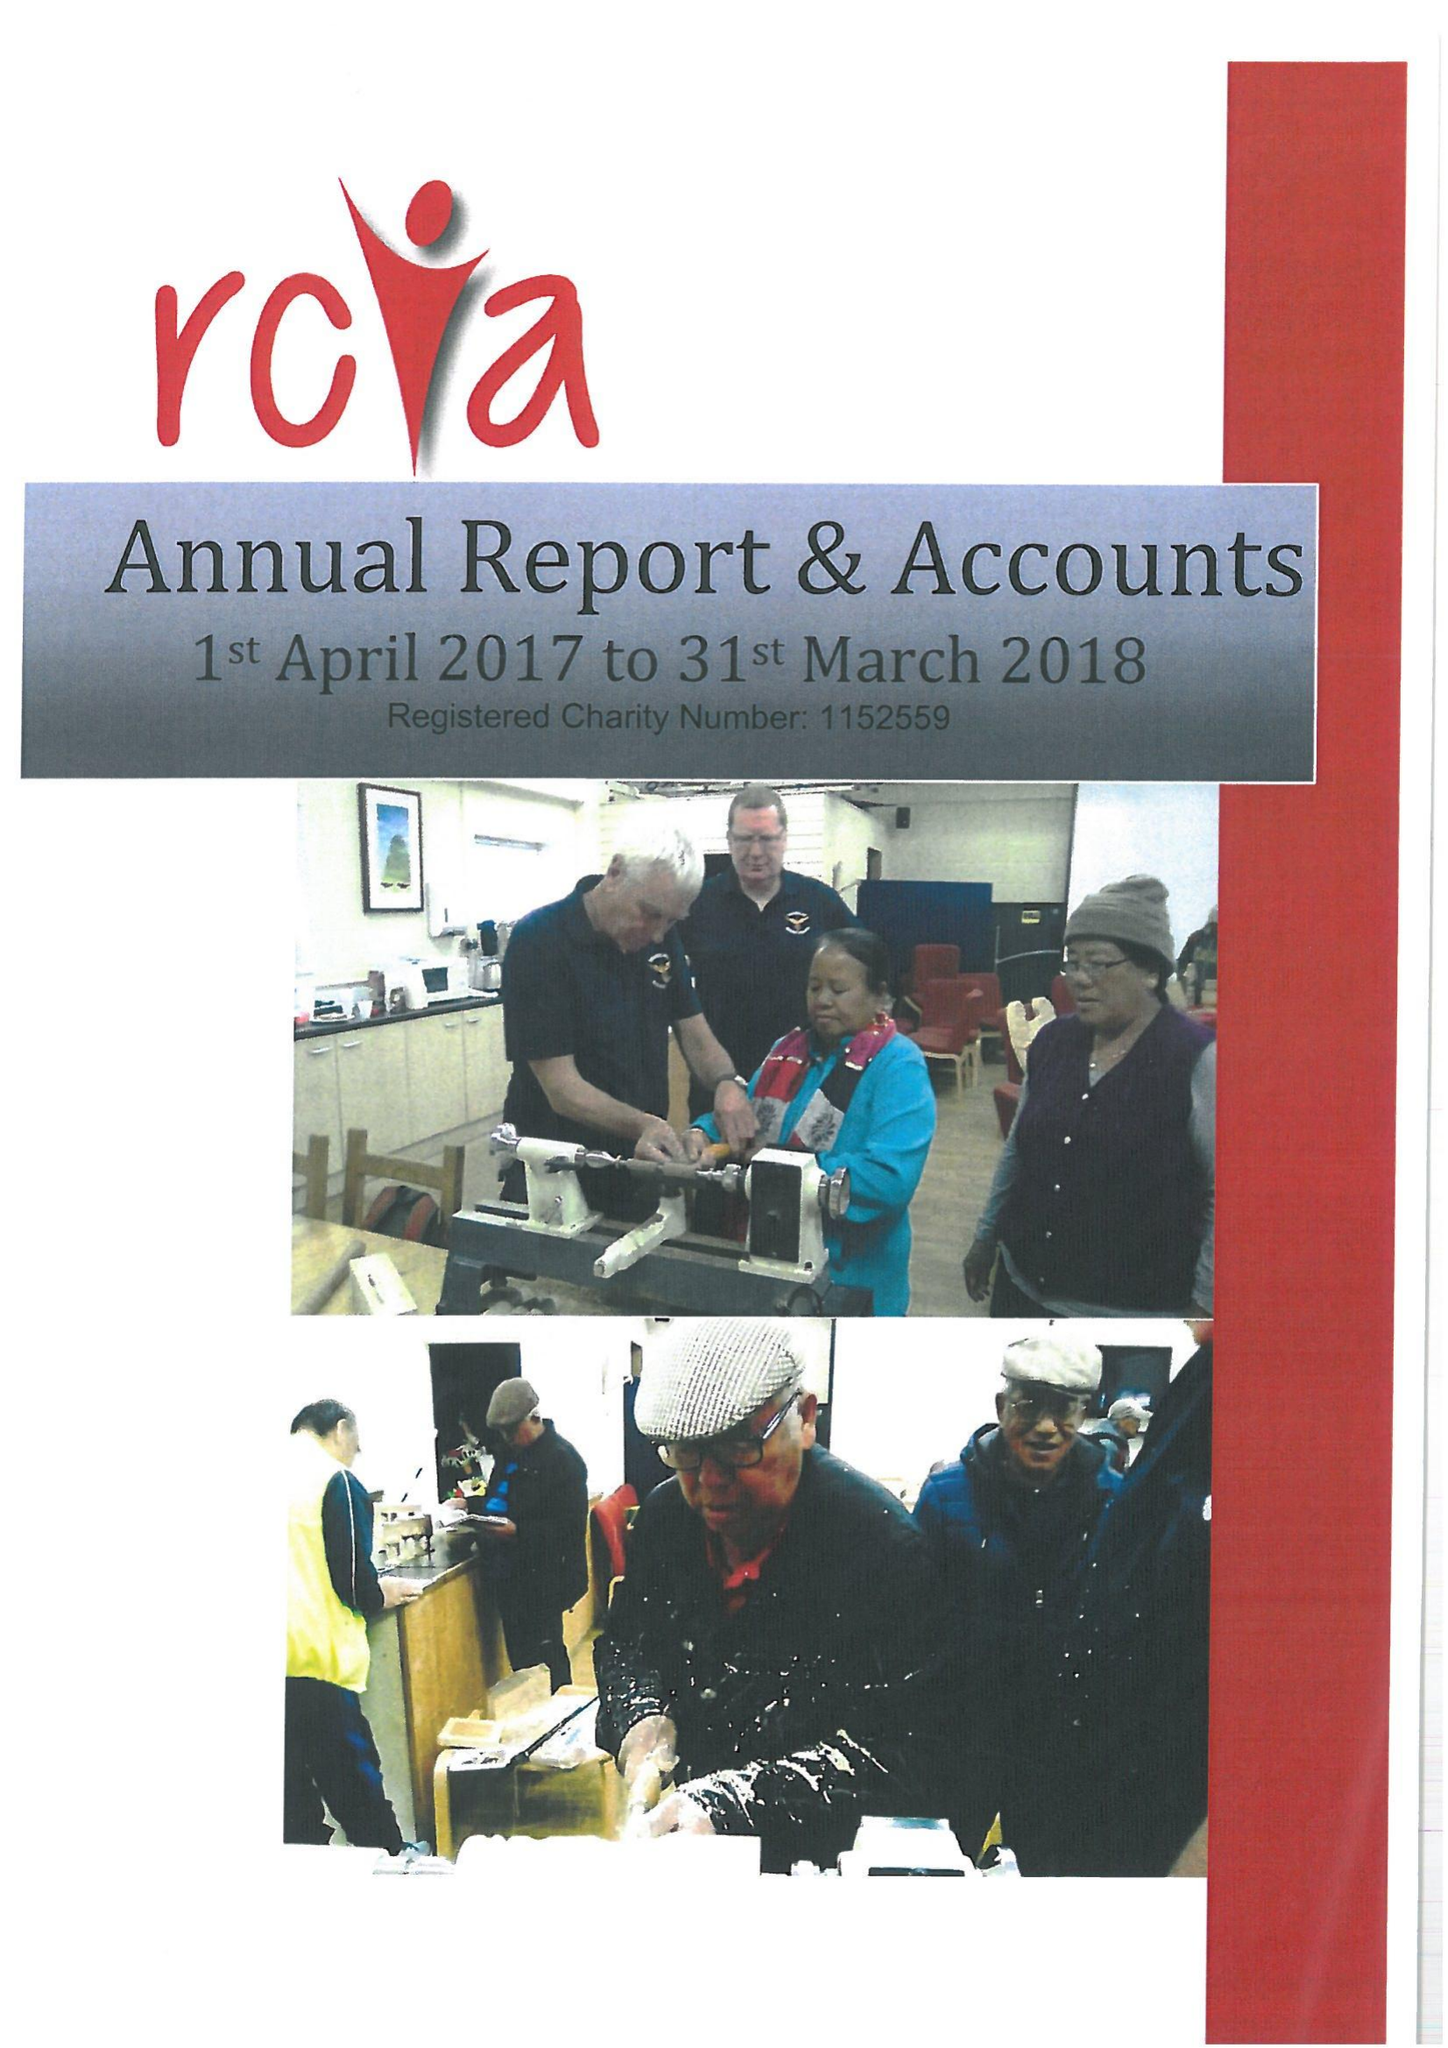What is the value for the income_annually_in_british_pounds?
Answer the question using a single word or phrase. 21413.00 